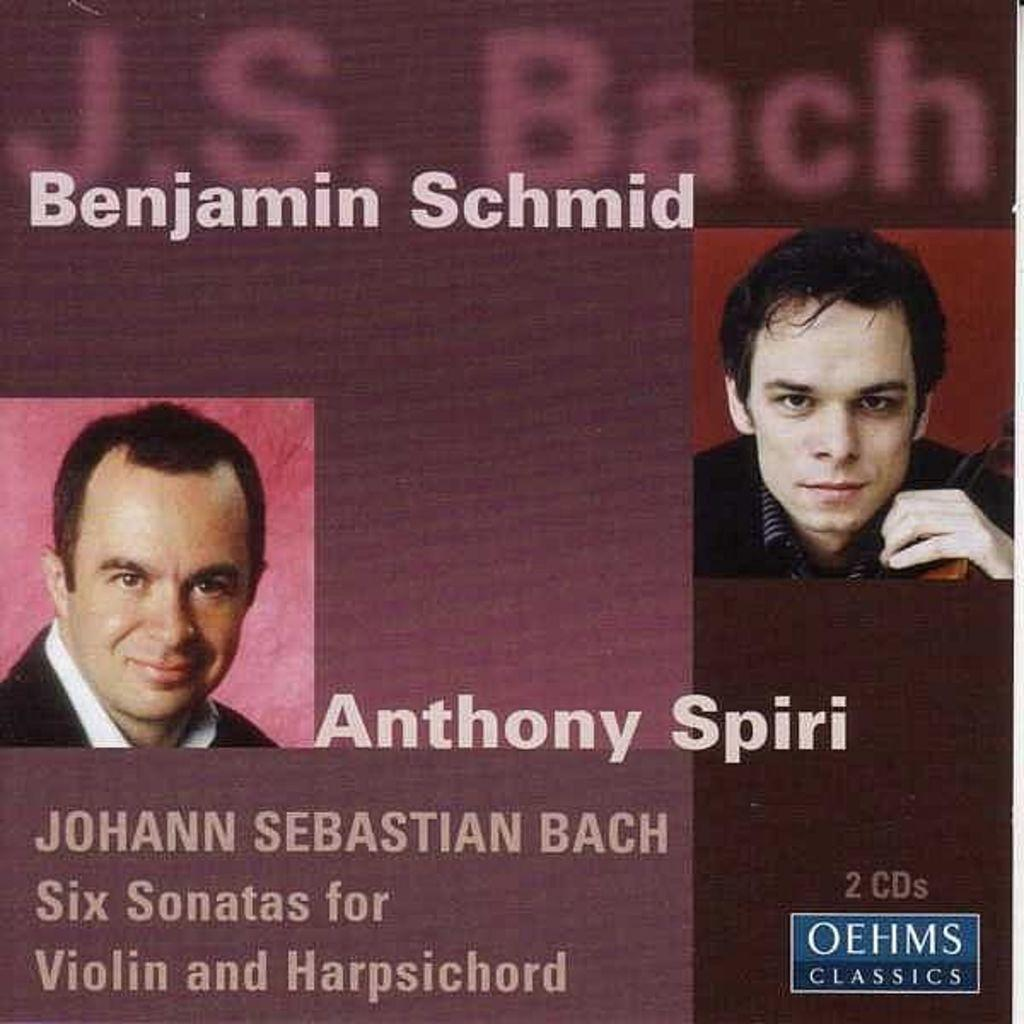What can be seen on the right and left sides of the image? There are men's faces on the right and left sides of the image. What is present at the bottom of the image? There is text at the bottom of the image. What is present at the top of the image? There is text at the top of the image. Can you tell me what type of vase is on the table in the image? There is no vase present in the image; it only features men's faces and text. What type of legal advice is the lawyer providing in the image? There is no lawyer or legal advice present in the image. 